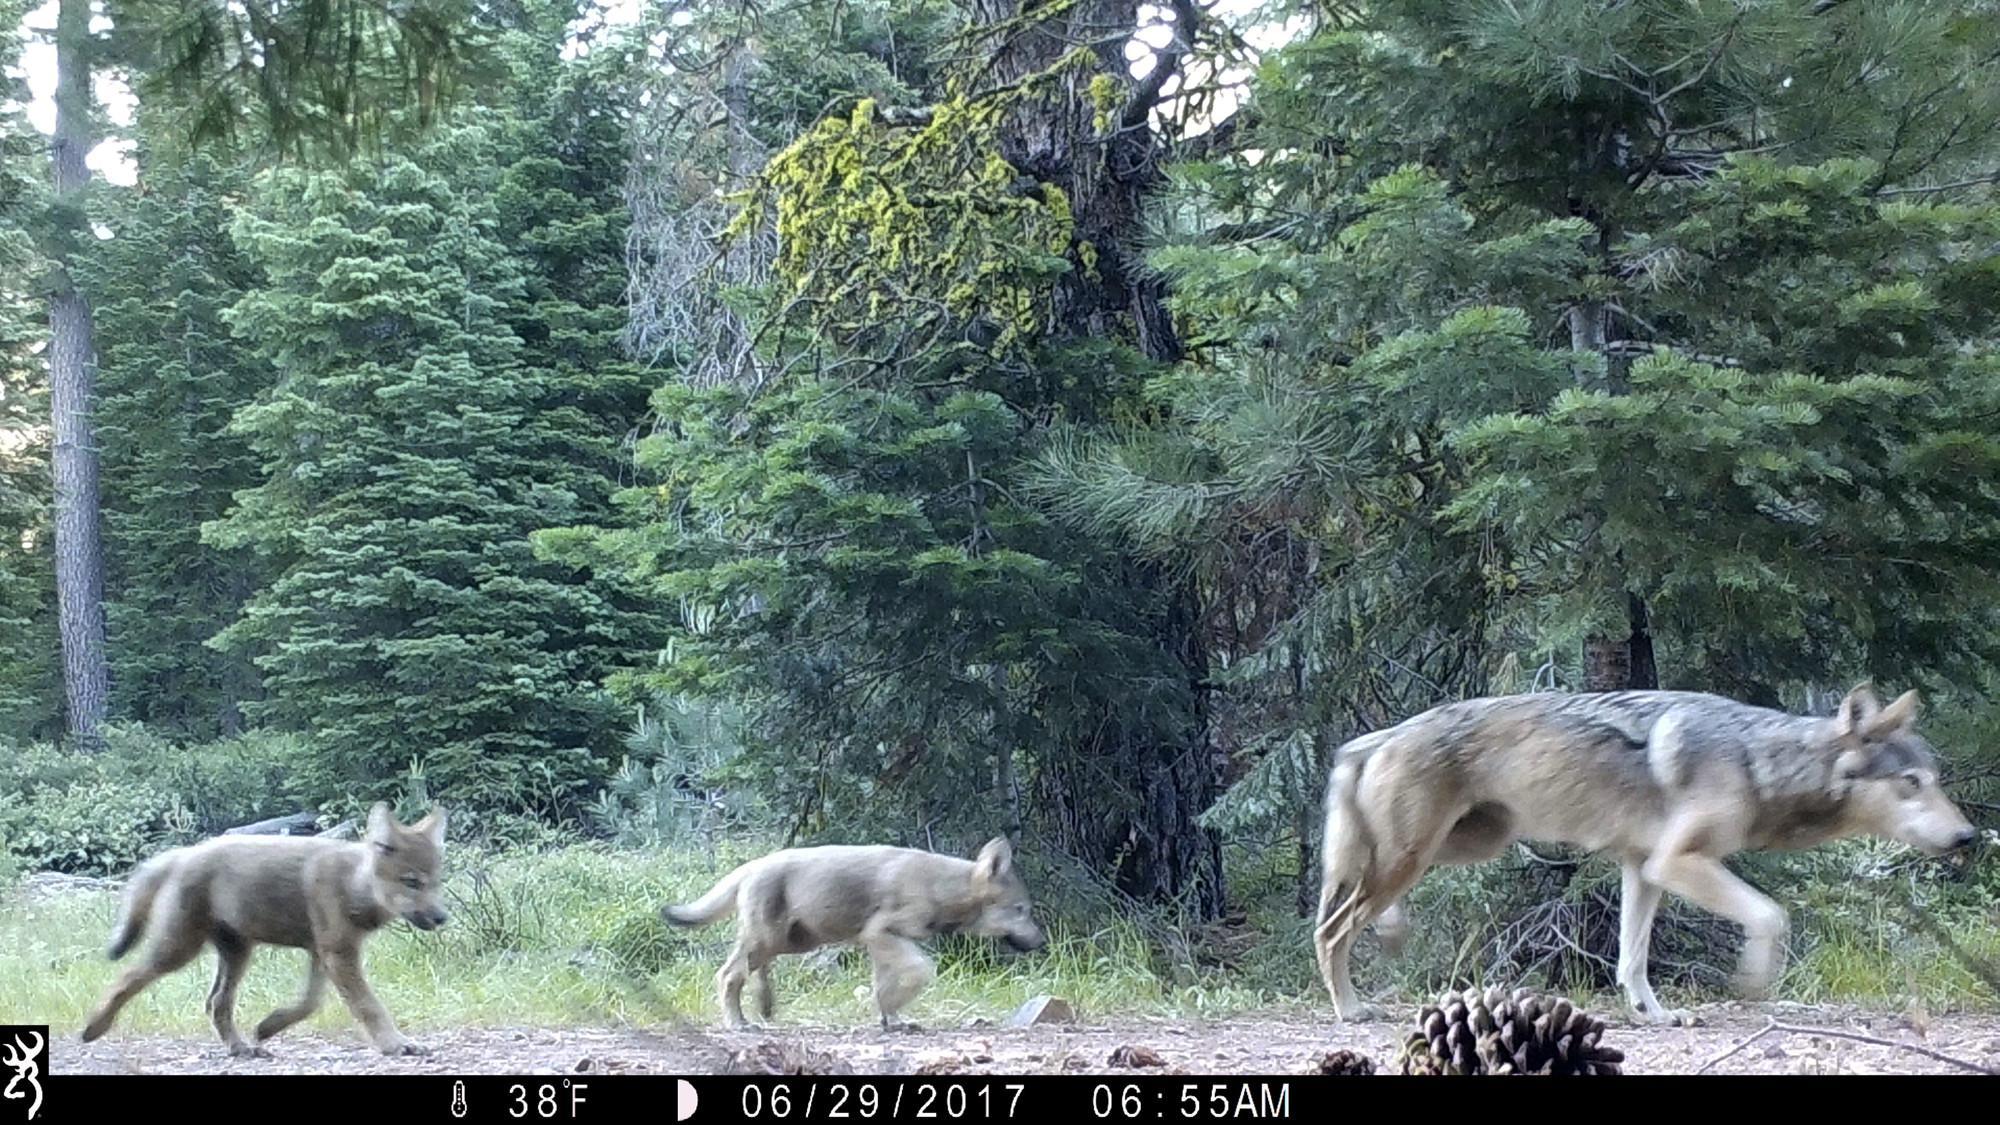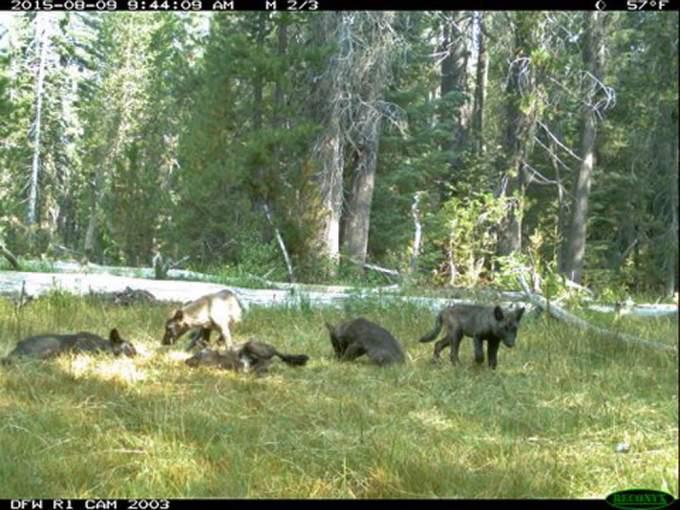The first image is the image on the left, the second image is the image on the right. For the images displayed, is the sentence "The image on the left includes at least one adult wolf standing on all fours, and the image on the right includes three wolf pups." factually correct? Answer yes or no. No. The first image is the image on the left, the second image is the image on the right. For the images shown, is this caption "Some of the wolves in one of the images are lying down on the ground." true? Answer yes or no. Yes. 